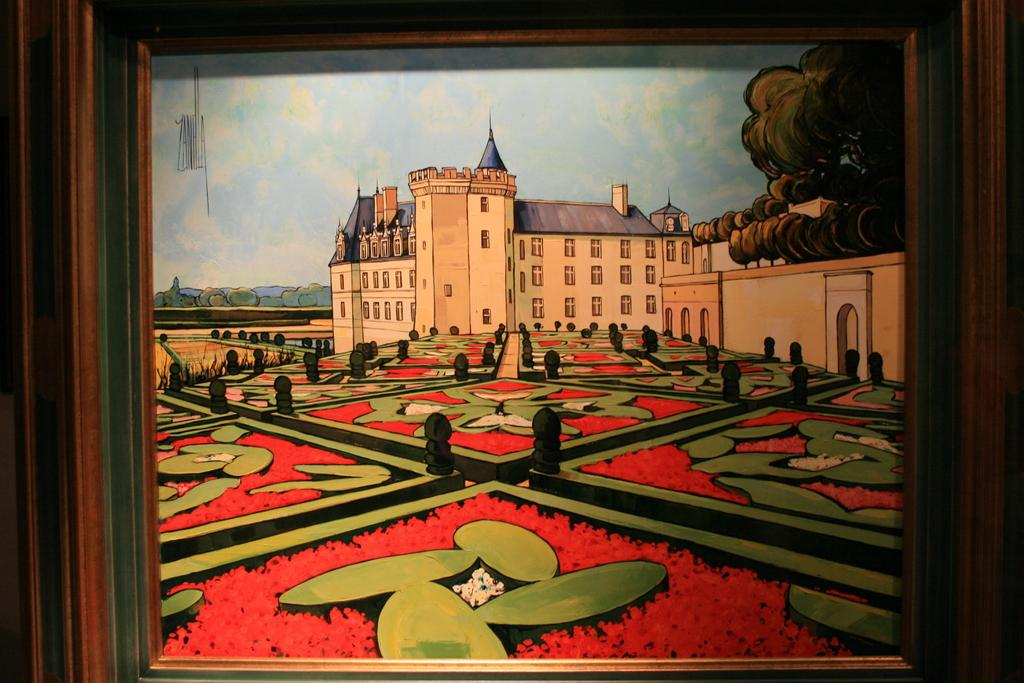What object is present in the image that contains an image? There is a photo frame in the image that contains a painting. What is depicted in the painting inside the photo frame? The painting depicts plants and flowers, as well as a building. What part of the natural environment is visible in the painting? The painting includes plants and flowers. What is visible at the top of the image? The sky is visible at the top of the image. How many children are playing in the transport depicted in the image? There is no depiction of children playing in a transport in the image. The image features a photo frame with a painting that includes plants, flowers, and a building, but no children or transport are present. 